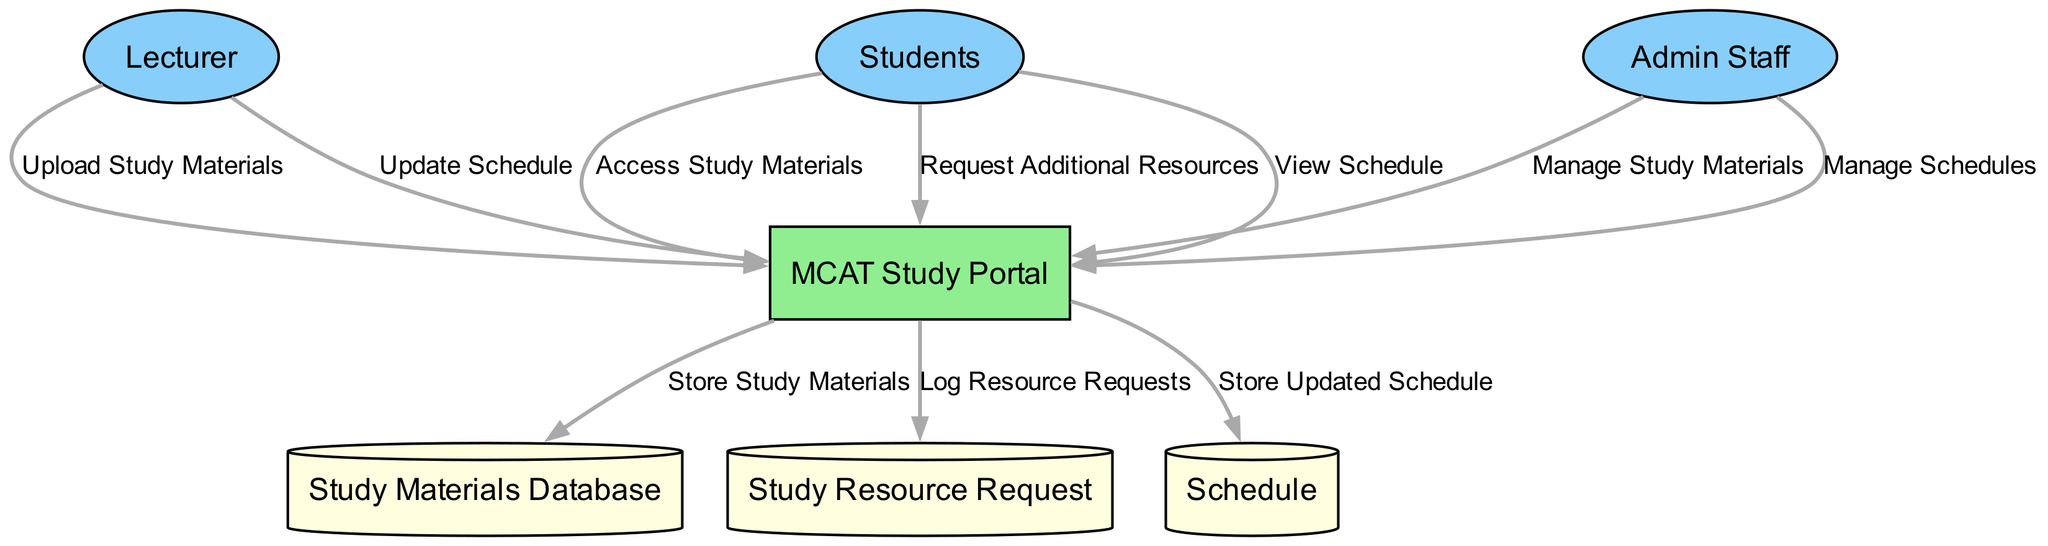What are the external entities in the diagram? By reviewing the nodes marked as "External Entity," we can identify that the external entities are the Lecturer, Students, and Admin Staff.
Answer: Lecturer, Students, Admin Staff How many data stores are present in the diagram? The diagram includes three data stores: Study Materials Database, Study Resource Request, and Schedule. Counting these gives us a total of three data stores.
Answer: 3 What action does the Lecturer perform in the MCAT Study Portal? The Lecturer uploads study materials to the MCAT Study Portal, as shown by the directed edge labeled "Upload Study Materials" from the Lecturer to the MCAT Study Portal.
Answer: Upload Study Materials Which entity requests additional resources? The Students are the ones who request additional resources, indicated by the arrow labeled "Request Additional Resources" directed from the Students to the MCAT Study Portal.
Answer: Students What is stored in the Study Materials Database? The Study Materials Database stores study materials, as specified by the flow that sends study materials from the MCAT Study Portal to the Study Materials Database, labeled "Store Study Materials."
Answer: Study Materials Which external entity manages schedules? The Admin Staff manages schedules, as indicated by the directed flow labeled "Manage Schedules" from the Admin Staff to the MCAT Study Portal.
Answer: Admin Staff What does the MCAT Study Portal do with resource requests? The MCAT Study Portal logs resource requests into the Study Resource Request data store, as depicted by the directed flow labeled "Log Resource Requests" from the MCAT Study Portal to the Study Resource Request.
Answer: Log Resource Requests Which entity views the schedule? The Students are the entity that views the schedule, shown by the arrow labeled "View Schedule" flowing from the Students to the MCAT Study Portal.
Answer: Students What is the purpose of the Schedule data store? The Schedule data store's purpose is to store the updated schedule as indicated by the flow from the MCAT Study Portal to the Schedule labeled "Store Updated Schedule."
Answer: Store Updated Schedule 